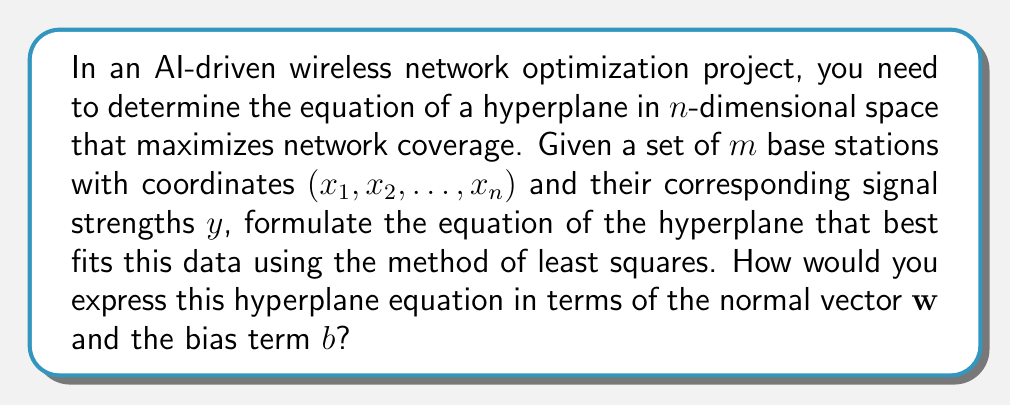Help me with this question. To determine the equation of the hyperplane that optimizes wireless network coverage, we'll follow these steps:

1) The general equation of a hyperplane in n-dimensional space is:

   $$w_1x_1 + w_2x_2 + ... + w_nx_n + b = 0$$

   Where $\mathbf{w} = (w_1, w_2, ..., w_n)$ is the normal vector to the hyperplane and $b$ is the bias term.

2) For our wireless network optimization, we want to find $\mathbf{w}$ and $b$ that best fit our data points. We can use the method of least squares.

3) Let's define our data matrix $X$ and target vector $y$:

   $$X = \begin{bmatrix}
   x_{11} & x_{12} & \cdots & x_{1n} & 1 \\
   x_{21} & x_{22} & \cdots & x_{2n} & 1 \\
   \vdots & \vdots & \ddots & \vdots & \vdots \\
   x_{m1} & x_{m2} & \cdots & x_{mn} & 1
   \end{bmatrix}, \quad y = \begin{bmatrix}
   y_1 \\
   y_2 \\
   \vdots \\
   y_m
   \end{bmatrix}$$

4) We want to find the vector $\beta = [\mathbf{w}^T, b]^T$ that minimizes the squared error:

   $$\min_\beta \|X\beta - y\|^2$$

5) The solution to this minimization problem is given by the normal equation:

   $$\beta = (X^TX)^{-1}X^Ty$$

6) Once we have $\beta$, we can extract $\mathbf{w}$ and $b$:

   $$\mathbf{w} = [\beta_1, \beta_2, ..., \beta_n]^T, \quad b = \beta_{n+1}$$

7) The equation of the hyperplane can then be expressed as:

   $$\mathbf{w}^T\mathbf{x} + b = 0$$

   Where $\mathbf{x} = [x_1, x_2, ..., x_n]^T$ is a point in the n-dimensional space.
Answer: $\mathbf{w}^T\mathbf{x} + b = 0$, where $\mathbf{w}$ and $b$ are derived from $\beta = (X^TX)^{-1}X^Ty$ 